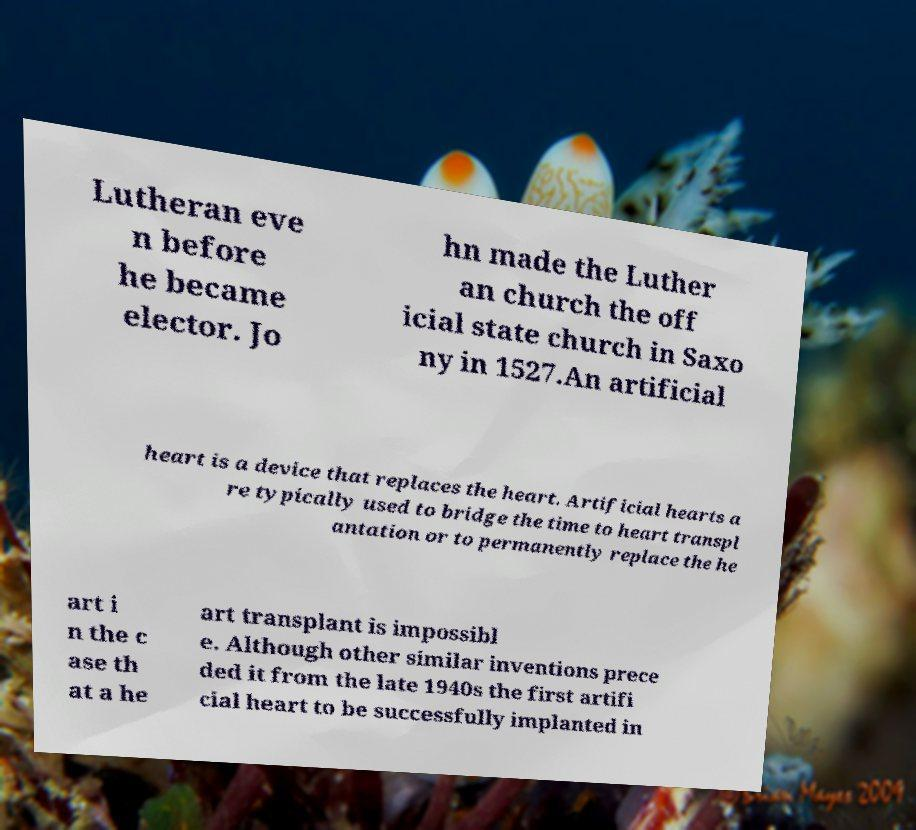Can you read and provide the text displayed in the image?This photo seems to have some interesting text. Can you extract and type it out for me? Lutheran eve n before he became elector. Jo hn made the Luther an church the off icial state church in Saxo ny in 1527.An artificial heart is a device that replaces the heart. Artificial hearts a re typically used to bridge the time to heart transpl antation or to permanently replace the he art i n the c ase th at a he art transplant is impossibl e. Although other similar inventions prece ded it from the late 1940s the first artifi cial heart to be successfully implanted in 